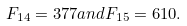Convert formula to latex. <formula><loc_0><loc_0><loc_500><loc_500>F _ { 1 4 } = 3 7 7 { a n d } F _ { 1 5 } = 6 1 0 .</formula> 